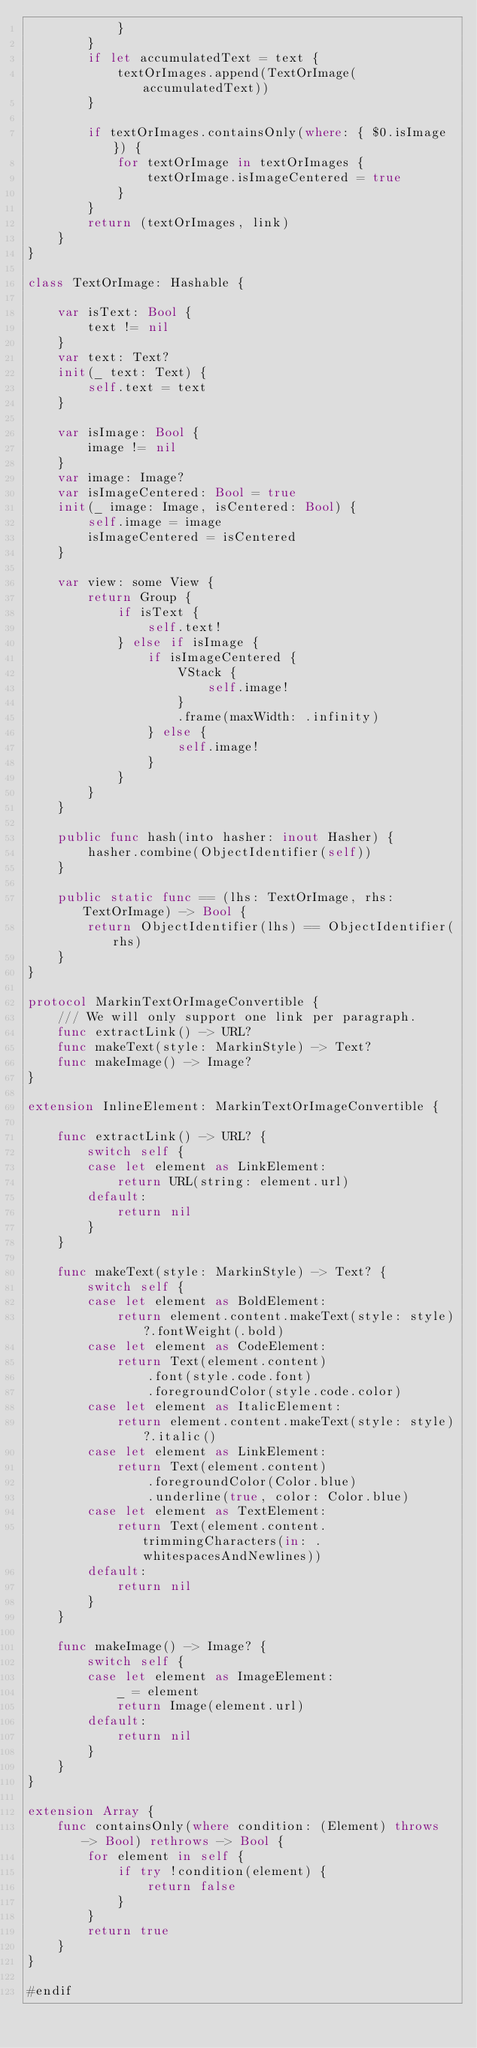<code> <loc_0><loc_0><loc_500><loc_500><_Swift_>            }
        }
        if let accumulatedText = text {
            textOrImages.append(TextOrImage(accumulatedText))
        }
        
        if textOrImages.containsOnly(where: { $0.isImage }) {
            for textOrImage in textOrImages {
                textOrImage.isImageCentered = true
            }
        }
        return (textOrImages, link)
    }
}

class TextOrImage: Hashable {
    
    var isText: Bool {
        text != nil
    }
    var text: Text?
    init(_ text: Text) {
        self.text = text
    }
    
    var isImage: Bool {
        image != nil
    }
    var image: Image?
    var isImageCentered: Bool = true
    init(_ image: Image, isCentered: Bool) {
        self.image = image
        isImageCentered = isCentered
    }
        
    var view: some View {
        return Group {
            if isText {
                self.text!
            } else if isImage {
                if isImageCentered {
                    VStack {
                        self.image!
                    }
                    .frame(maxWidth: .infinity)
                } else {
                    self.image!
                }
            }
        }
    }
    
    public func hash(into hasher: inout Hasher) {
        hasher.combine(ObjectIdentifier(self))
    }
    
    public static func == (lhs: TextOrImage, rhs: TextOrImage) -> Bool {
        return ObjectIdentifier(lhs) == ObjectIdentifier(rhs)
    }
}

protocol MarkinTextOrImageConvertible {
    /// We will only support one link per paragraph.
    func extractLink() -> URL?
    func makeText(style: MarkinStyle) -> Text?
    func makeImage() -> Image?
}

extension InlineElement: MarkinTextOrImageConvertible {
    
    func extractLink() -> URL? {
        switch self {
        case let element as LinkElement:
            return URL(string: element.url)
        default:
            return nil
        }
    }
    
    func makeText(style: MarkinStyle) -> Text? {
        switch self {
        case let element as BoldElement:
            return element.content.makeText(style: style)?.fontWeight(.bold)
        case let element as CodeElement:
            return Text(element.content)
                .font(style.code.font)
                .foregroundColor(style.code.color)
        case let element as ItalicElement:
            return element.content.makeText(style: style)?.italic()
        case let element as LinkElement:
            return Text(element.content)
                .foregroundColor(Color.blue)
                .underline(true, color: Color.blue)
        case let element as TextElement:
            return Text(element.content.trimmingCharacters(in: .whitespacesAndNewlines))
        default:
            return nil
        }
    }
    
    func makeImage() -> Image? {
        switch self {
        case let element as ImageElement:
            _ = element
            return Image(element.url)
        default:
            return nil
        }
    }
}

extension Array {
    func containsOnly(where condition: (Element) throws -> Bool) rethrows -> Bool {
        for element in self {
            if try !condition(element) {
                return false
            }
        }
        return true
    }
}

#endif
</code> 